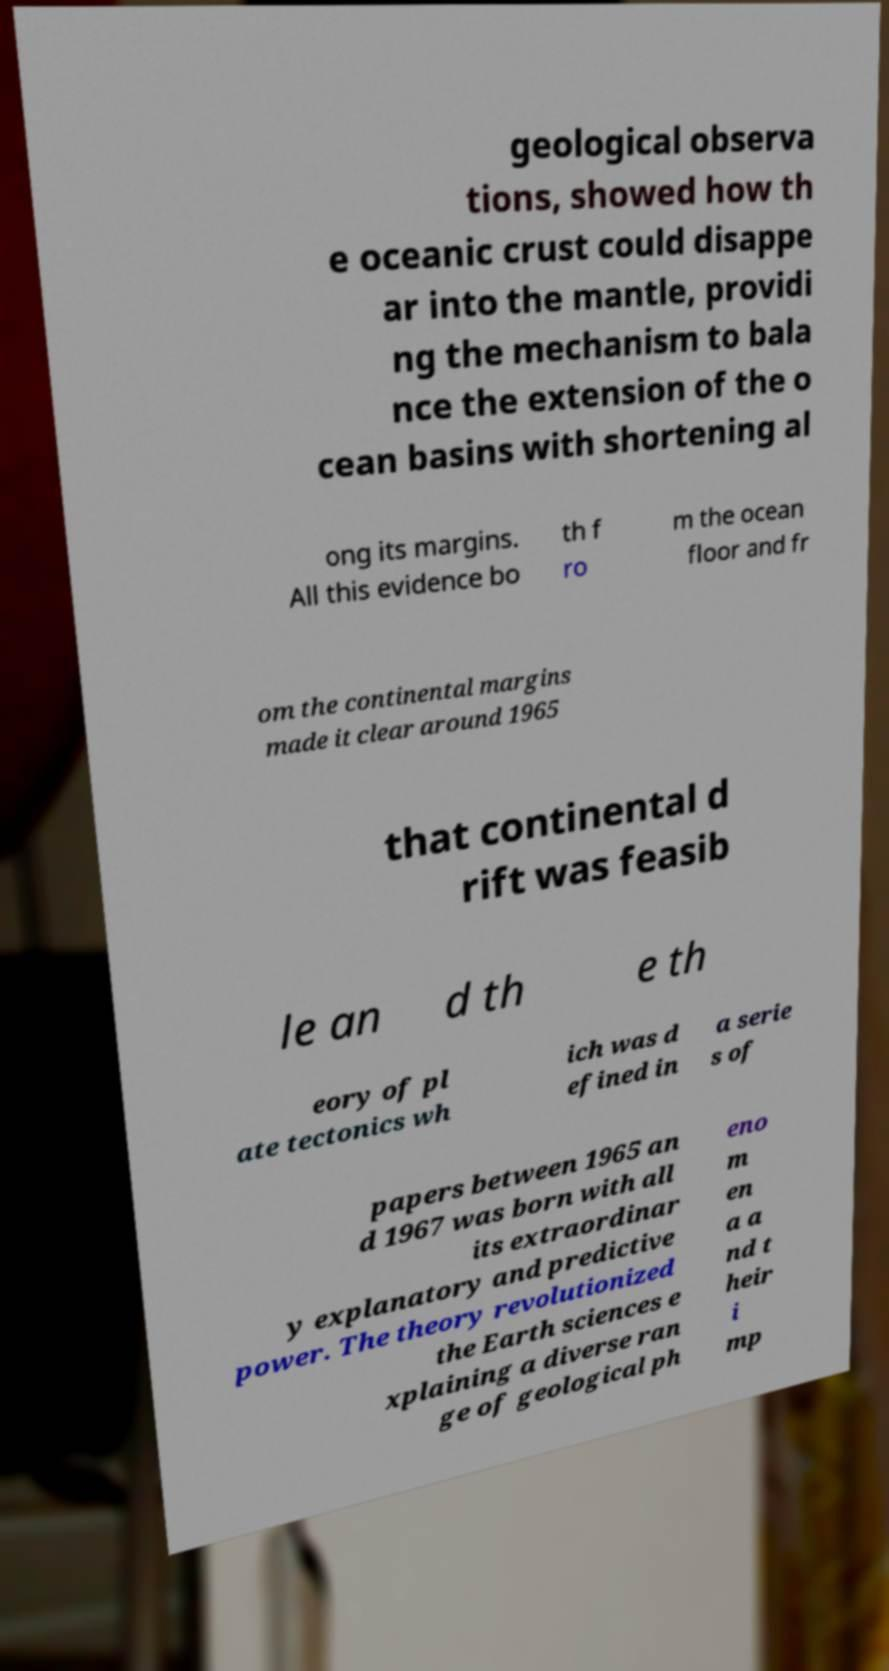Can you read and provide the text displayed in the image?This photo seems to have some interesting text. Can you extract and type it out for me? geological observa tions, showed how th e oceanic crust could disappe ar into the mantle, providi ng the mechanism to bala nce the extension of the o cean basins with shortening al ong its margins. All this evidence bo th f ro m the ocean floor and fr om the continental margins made it clear around 1965 that continental d rift was feasib le an d th e th eory of pl ate tectonics wh ich was d efined in a serie s of papers between 1965 an d 1967 was born with all its extraordinar y explanatory and predictive power. The theory revolutionized the Earth sciences e xplaining a diverse ran ge of geological ph eno m en a a nd t heir i mp 